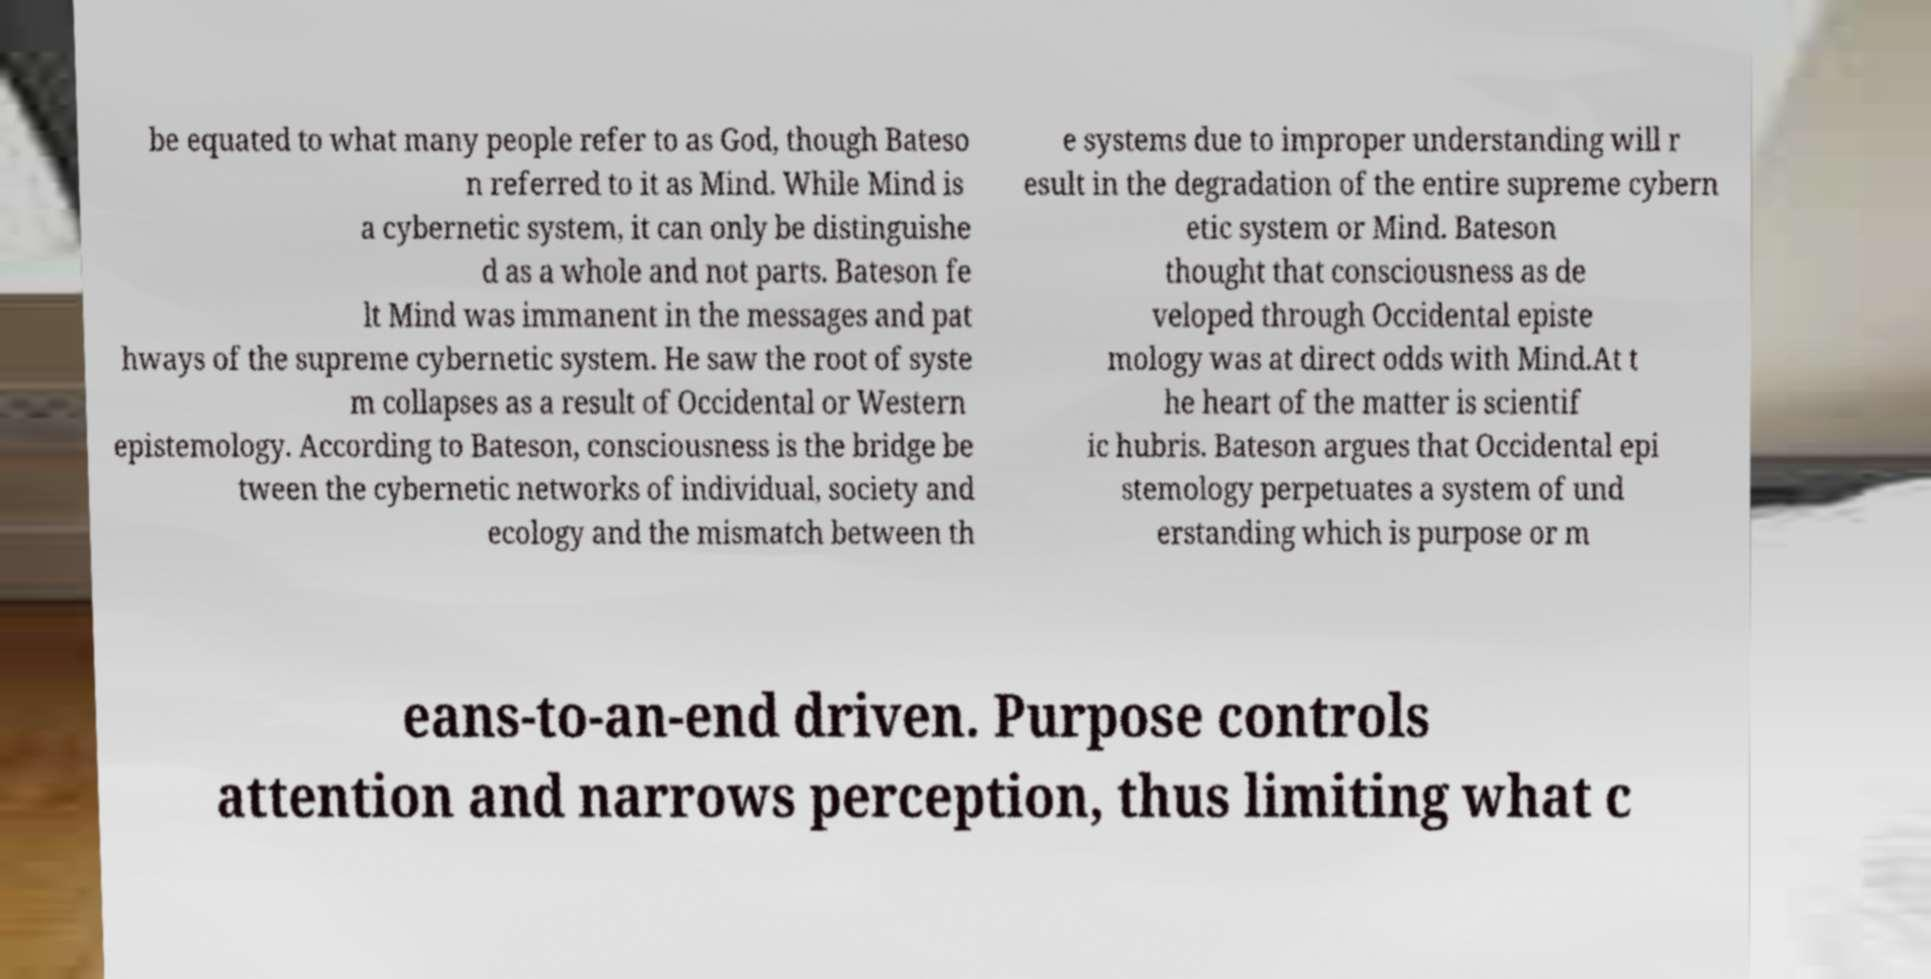Can you accurately transcribe the text from the provided image for me? be equated to what many people refer to as God, though Bateso n referred to it as Mind. While Mind is a cybernetic system, it can only be distinguishe d as a whole and not parts. Bateson fe lt Mind was immanent in the messages and pat hways of the supreme cybernetic system. He saw the root of syste m collapses as a result of Occidental or Western epistemology. According to Bateson, consciousness is the bridge be tween the cybernetic networks of individual, society and ecology and the mismatch between th e systems due to improper understanding will r esult in the degradation of the entire supreme cybern etic system or Mind. Bateson thought that consciousness as de veloped through Occidental episte mology was at direct odds with Mind.At t he heart of the matter is scientif ic hubris. Bateson argues that Occidental epi stemology perpetuates a system of und erstanding which is purpose or m eans-to-an-end driven. Purpose controls attention and narrows perception, thus limiting what c 